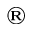<formula> <loc_0><loc_0><loc_500><loc_500>^ { \text  }registered</formula> 